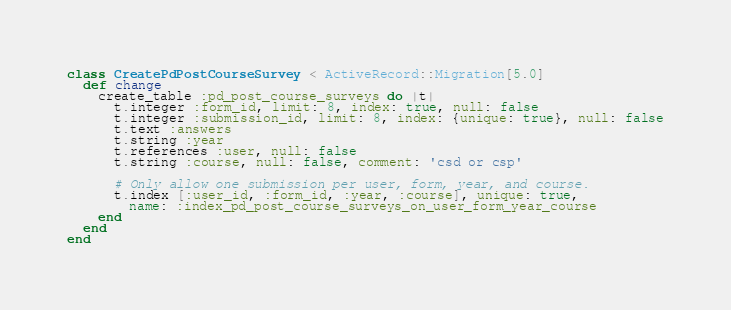Convert code to text. <code><loc_0><loc_0><loc_500><loc_500><_Ruby_>class CreatePdPostCourseSurvey < ActiveRecord::Migration[5.0]
  def change
    create_table :pd_post_course_surveys do |t|
      t.integer :form_id, limit: 8, index: true, null: false
      t.integer :submission_id, limit: 8, index: {unique: true}, null: false
      t.text :answers
      t.string :year
      t.references :user, null: false
      t.string :course, null: false, comment: 'csd or csp'

      # Only allow one submission per user, form, year, and course.
      t.index [:user_id, :form_id, :year, :course], unique: true,
        name: :index_pd_post_course_surveys_on_user_form_year_course
    end
  end
end
</code> 